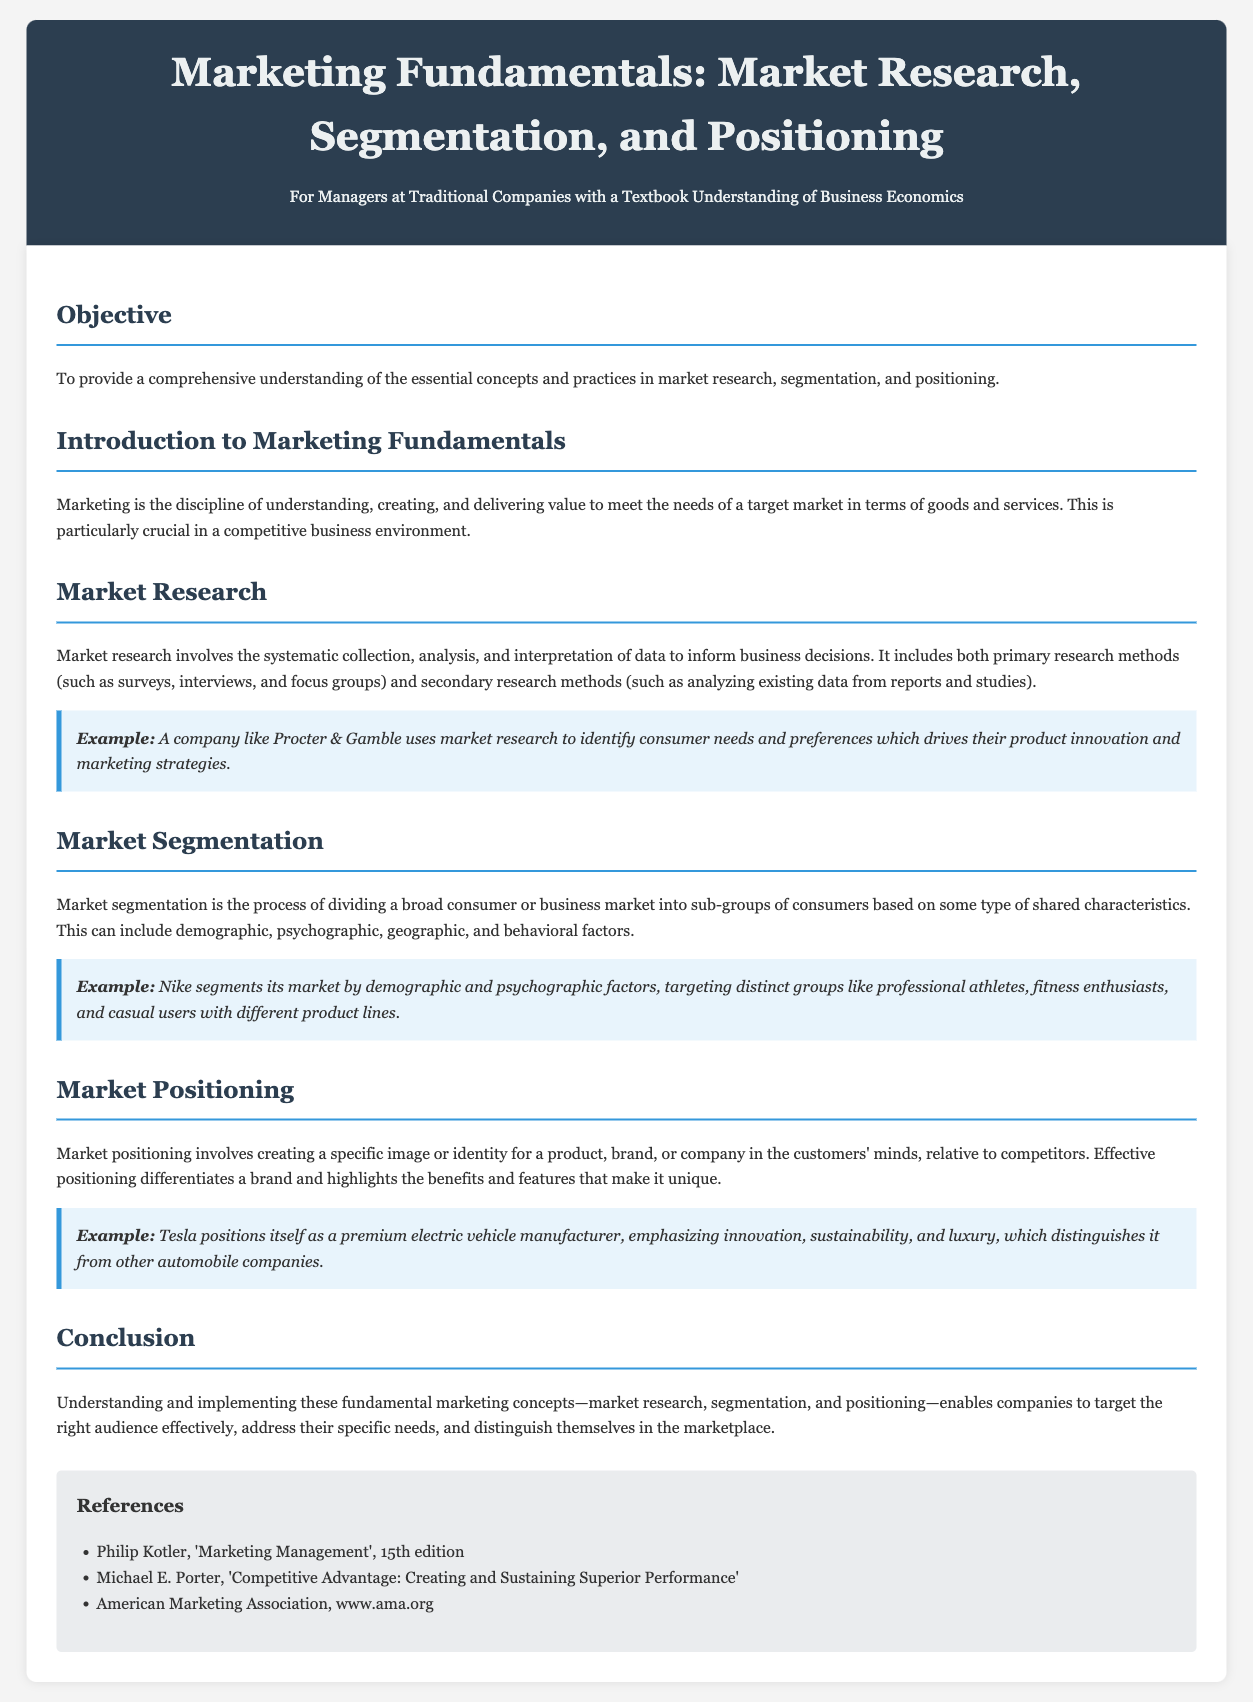What is the objective of the lesson? The objective is stated in the document as providing a comprehensive understanding of the essential concepts and practices in market research, segmentation, and positioning.
Answer: Comprehensive understanding What type of research methods does market research include? The document specifies that market research includes primary research methods and secondary research methods.
Answer: Primary and secondary What company is mentioned as an example of using market research? The example given in the document specifically mentions Procter & Gamble in relation to market research.
Answer: Procter & Gamble What factors does market segmentation consider? The document lists demographic, psychographic, geographic, and behavioral factors for market segmentation.
Answer: Demographic, psychographic, geographic, behavioral How does Tesla position itself in the market? According to the document, Tesla positions itself as a premium electric vehicle manufacturer emphasizing innovation, sustainability, and luxury.
Answer: Premium electric vehicle manufacturer What are the three fundamental marketing concepts highlighted in the conclusion? The conclusion mentions market research, segmentation, and positioning as the three fundamental concepts.
Answer: Market research, segmentation, positioning Which reference is listed for 'Marketing Management'? The document cites Philip Kotler's 'Marketing Management', 15th edition, as a reference.
Answer: Philip Kotler, 'Marketing Management', 15th edition What is the document aimed at? The introduction states that the lesson is aimed at managers at traditional companies with a textbook understanding of business economics.
Answer: Managers at traditional companies What does effective positioning do according to the document? The document states that effective positioning differentiates a brand and highlights its benefits and features.
Answer: Differentiates a brand 